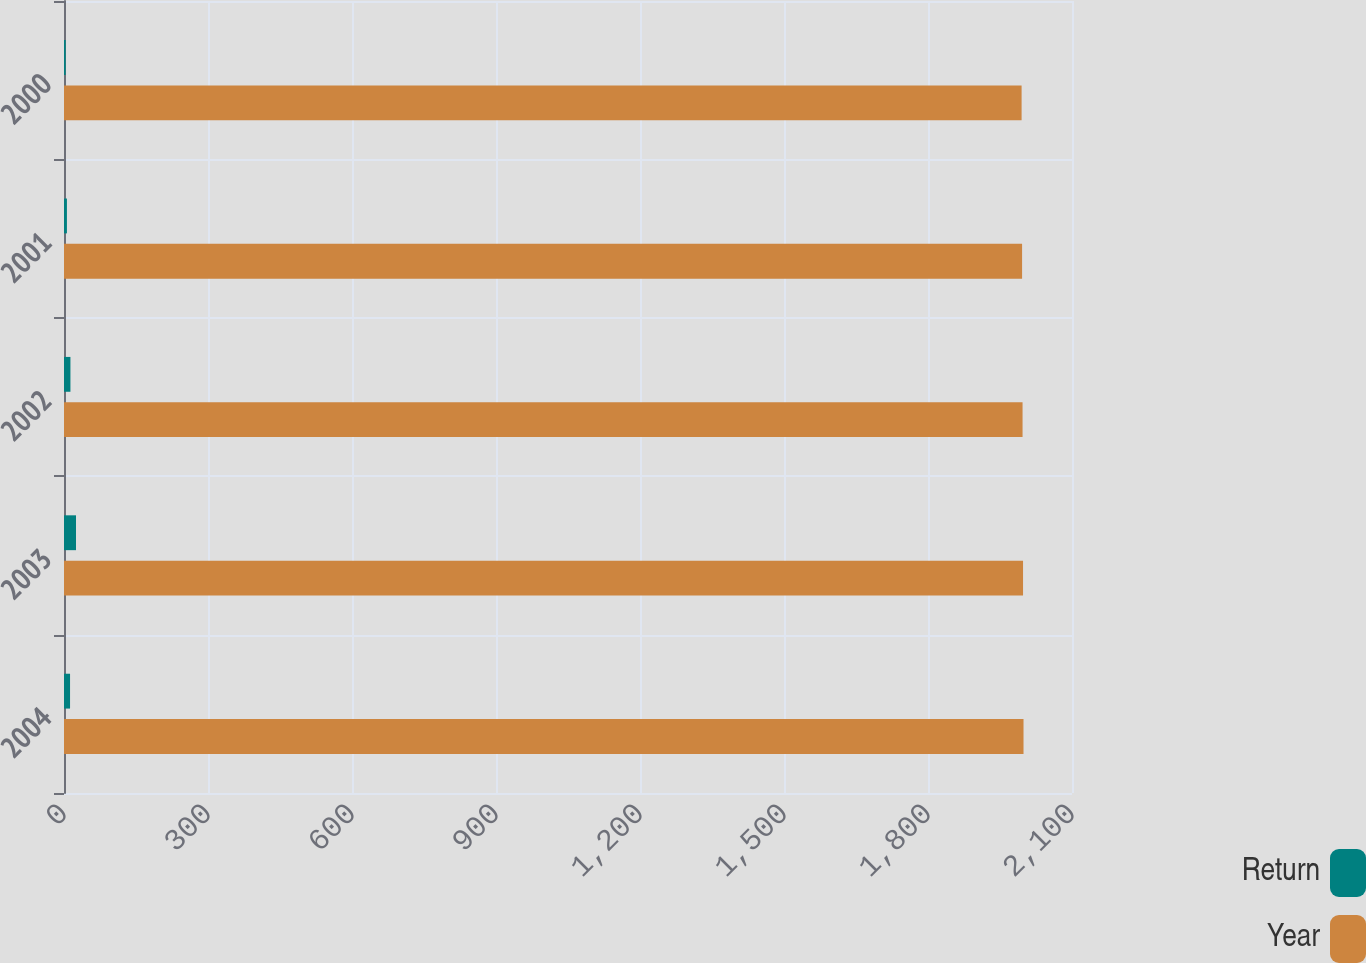<chart> <loc_0><loc_0><loc_500><loc_500><stacked_bar_chart><ecel><fcel>2004<fcel>2003<fcel>2002<fcel>2001<fcel>2000<nl><fcel>Return<fcel>12.6<fcel>25<fcel>13.4<fcel>6.1<fcel>3.5<nl><fcel>Year<fcel>1999<fcel>1998<fcel>1997<fcel>1996<fcel>1995<nl></chart> 